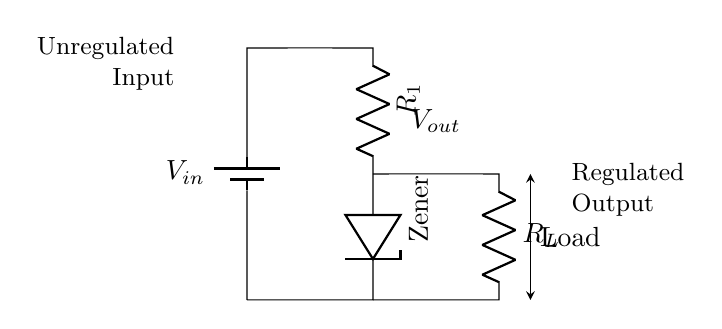What is the type of voltage regulation used in this circuit? The circuit uses a Zener diode for voltage regulation, which allows for a stable output voltage by conducting in reverse at a specific voltage.
Answer: Zener diode What component provides the input voltage? The battery, labeled as V in the circuit, serves as the input voltage source that powers the voltage regulator circuit.
Answer: Battery What is the role of resistor R1 in this circuit? Resistor R1 is used to limit the current flowing through the Zener diode to prevent it from exceeding its maximum rating, ensuring safe operation.
Answer: Current limiting What is the expected output voltage across the load R_L? The output voltage is approximately the Zener breakdown voltage because the Zener diode stabilizes the voltage at this level, irrespective of variations in input voltage.
Answer: Zener voltage If the load resistance R_L decreases, what happens to the output voltage? As the load resistance R_L decreases, the output voltage remains regulated as long as the input voltage is above the Zener breakdown voltage, but excessive load may affect stability.
Answer: Regulated output What is the output voltage label in the circuit? The output voltage is labeled V out, indicating the voltage at the point where the load connects to the regulator.
Answer: V out How does this circuit stabilize the voltage for small appliances? The circuit stabilizes voltage by utilizing the Zener diode to maintain a constant output voltage despite variations in input voltage or load, making it reliable for small appliances.
Answer: Voltage stabilization 